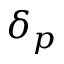<formula> <loc_0><loc_0><loc_500><loc_500>\delta _ { p }</formula> 